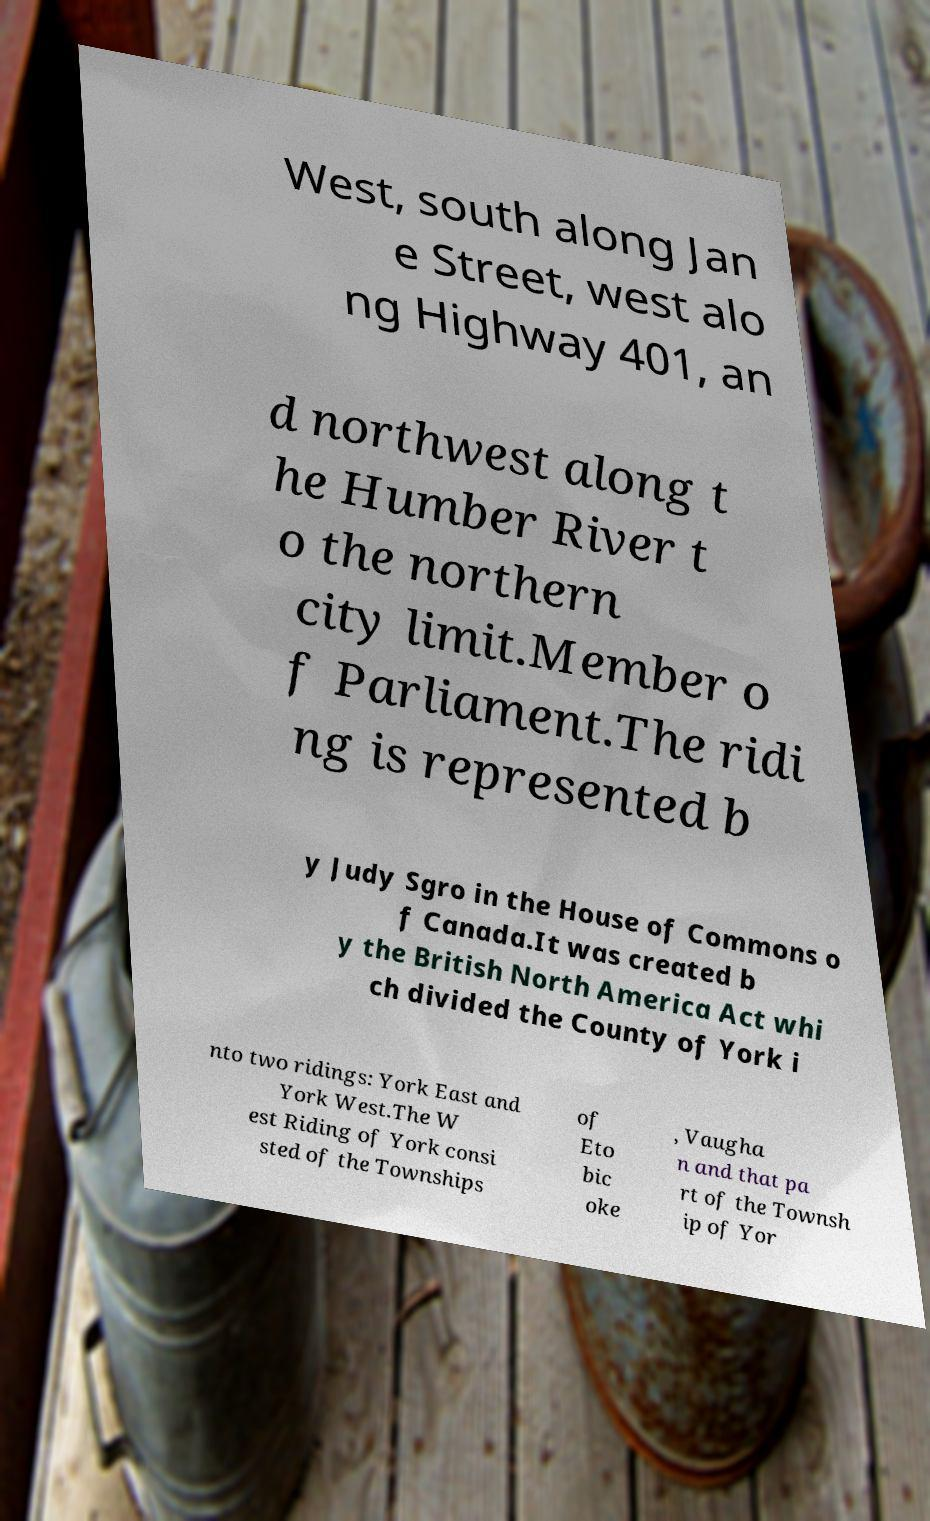For documentation purposes, I need the text within this image transcribed. Could you provide that? West, south along Jan e Street, west alo ng Highway 401, an d northwest along t he Humber River t o the northern city limit.Member o f Parliament.The ridi ng is represented b y Judy Sgro in the House of Commons o f Canada.It was created b y the British North America Act whi ch divided the County of York i nto two ridings: York East and York West.The W est Riding of York consi sted of the Townships of Eto bic oke , Vaugha n and that pa rt of the Townsh ip of Yor 